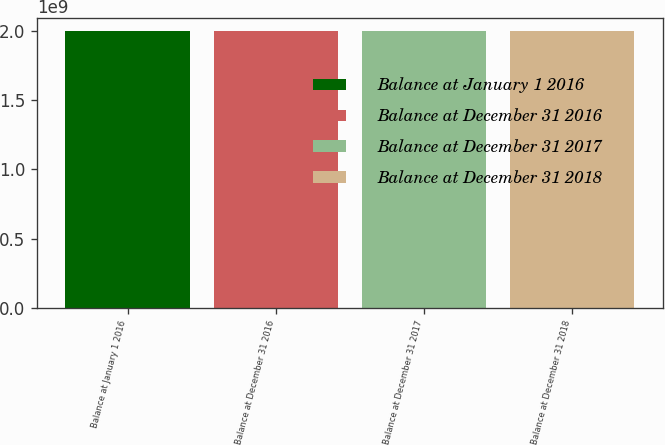Convert chart. <chart><loc_0><loc_0><loc_500><loc_500><bar_chart><fcel>Balance at January 1 2016<fcel>Balance at December 31 2016<fcel>Balance at December 31 2017<fcel>Balance at December 31 2018<nl><fcel>1.99654e+09<fcel>1.99654e+09<fcel>1.99654e+09<fcel>1.99654e+09<nl></chart> 